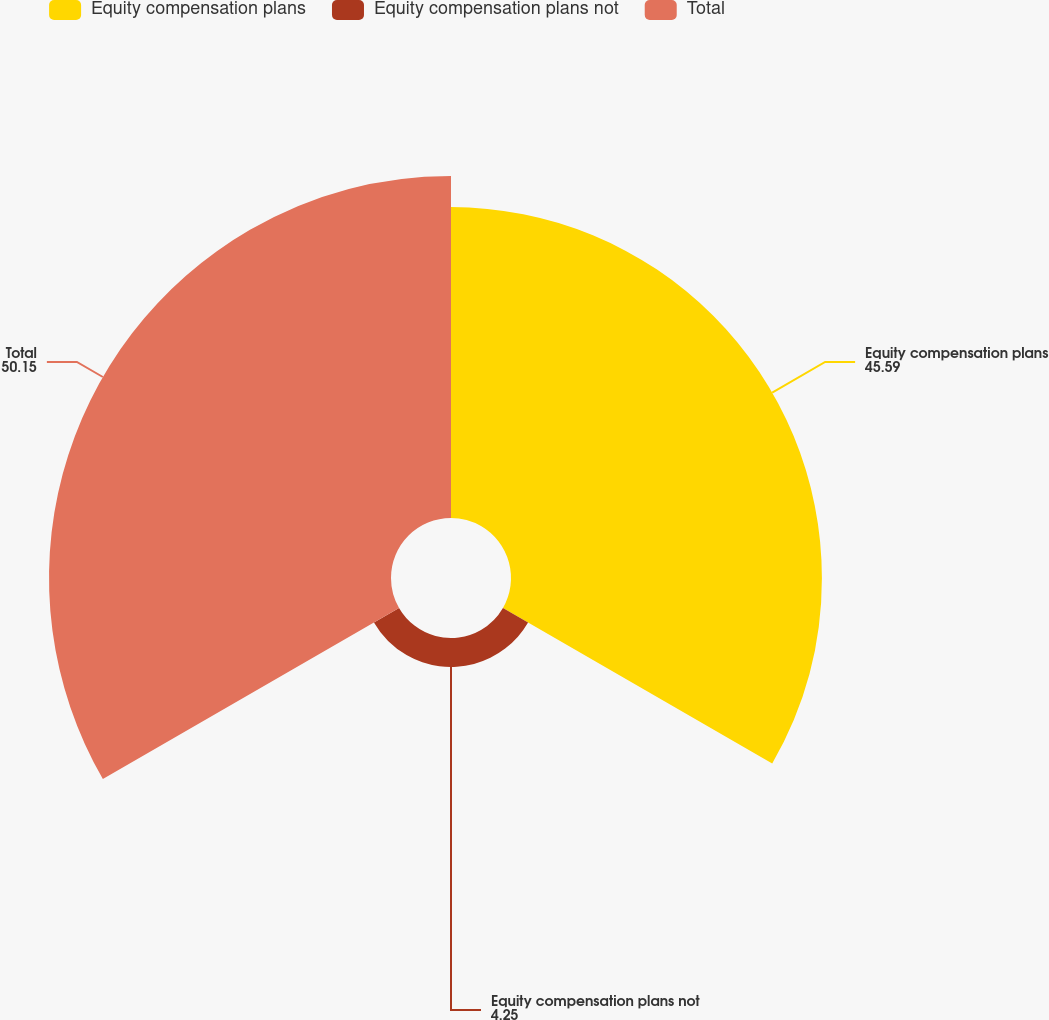<chart> <loc_0><loc_0><loc_500><loc_500><pie_chart><fcel>Equity compensation plans<fcel>Equity compensation plans not<fcel>Total<nl><fcel>45.59%<fcel>4.25%<fcel>50.15%<nl></chart> 